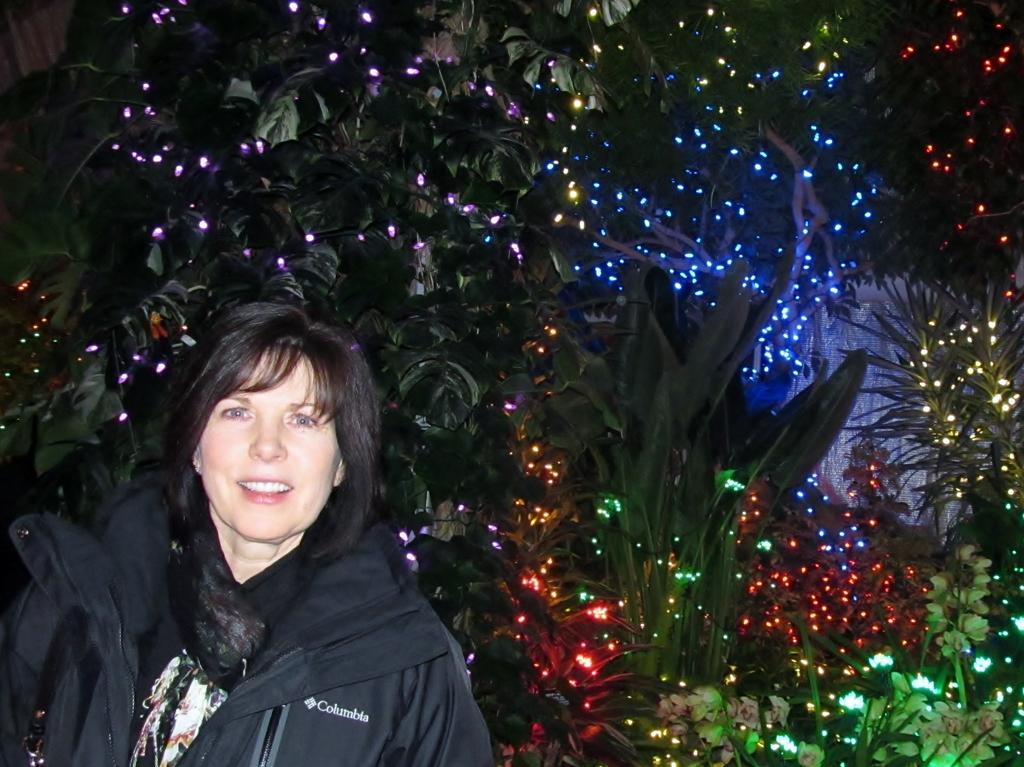How would you summarize this image in a sentence or two? In this image we can see a woman smiling. In the background we can see the plants and also the trees with the lights. 